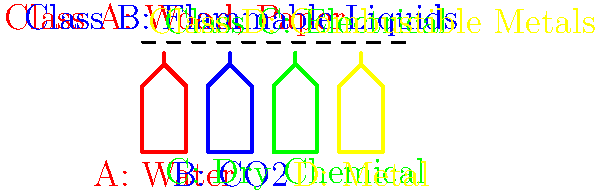Based on the diagram showing different types of fire extinguishers and fire classes, which extinguisher would be most effective for a fire involving electrical equipment in an office setting? To determine the most effective fire extinguisher for electrical equipment, let's analyze the information provided:

1. The diagram shows four types of fire extinguishers: A (Water), B (CO2), C (Dry Chemical), and D (Metal).

2. It also lists four classes of fires:
   - Class A: Wood, Paper
   - Class B: Flammable Liquids
   - Class C: Electrical
   - Class D: Combustible Metals

3. For electrical fires (Class C), we need to consider two important factors:
   a) The extinguishing agent should not conduct electricity, as this could pose a risk to the person using the extinguisher.
   b) The agent should effectively suppress the fire without causing additional damage to the electrical equipment.

4. Analyzing the options:
   - Water (A) is not suitable for electrical fires as it conducts electricity and can cause short circuits or electrocution.
   - CO2 (B) is non-conductive and leaves no residue, making it suitable for electrical fires.
   - Dry Chemical (C) is also non-conductive and effective for electrical fires, but it may leave a residue that could damage sensitive equipment.
   - Metal (D) is specifically designed for combustible metal fires and is not appropriate for electrical fires.

5. Given that the question specifies an office setting, where minimal damage to equipment is desirable, the CO2 extinguisher (B) would be the most effective choice.
Answer: CO2 (B) extinguisher 